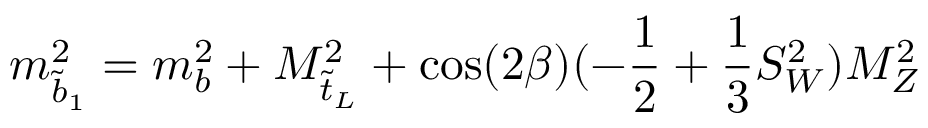<formula> <loc_0><loc_0><loc_500><loc_500>m _ { \tilde { b } _ { 1 } } ^ { 2 } = m _ { b } ^ { 2 } + M _ { \tilde { t } _ { L } } ^ { 2 } + \cos ( 2 \beta ) ( - \frac { 1 } { 2 } + \frac { 1 } { 3 } S _ { W } ^ { 2 } ) M _ { Z } ^ { 2 }</formula> 